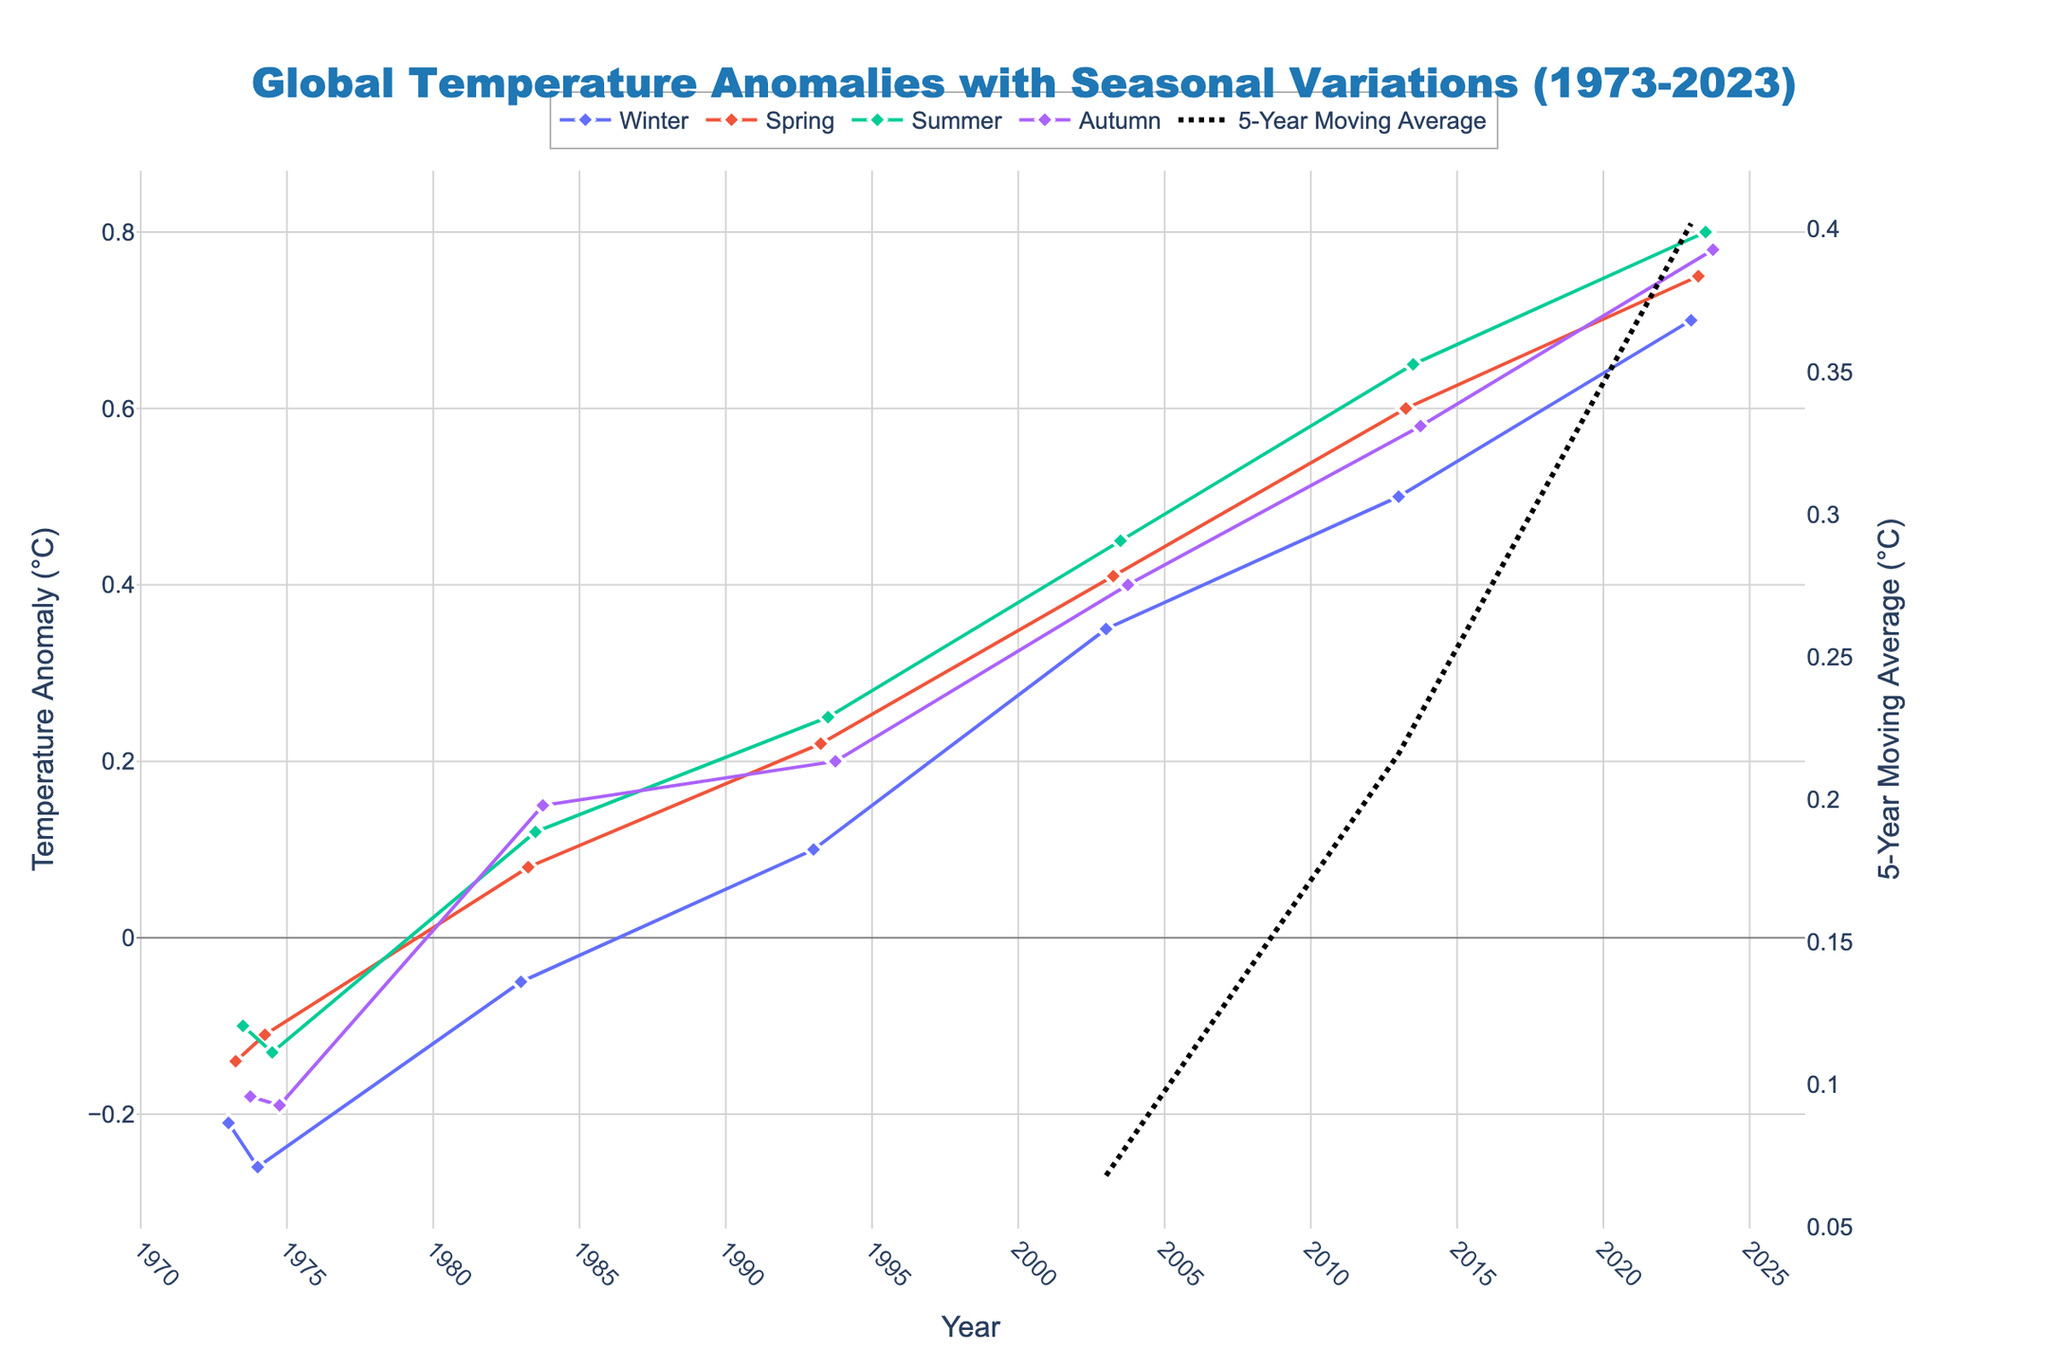What's the title of the figure? The title of the figure is displayed at the top center and reads "Global Temperature Anomalies with Seasonal Variations (1973-2023)"
Answer: Global Temperature Anomalies with Seasonal Variations (1973-2023) What are the y-axis labels? There are two y-axis labels on the figure. The label on the left y-axis reads "Temperature Anomaly (°C)", and the label on the right y-axis reads "5-Year Moving Average (°C)"
Answer: Temperature Anomaly (°C) and 5-Year Moving Average (°C) How does the temperature anomaly in Winter 2023 compare with Summer 2023? To compare the temperature anomaly values for Winter 2023 and Summer 2023, we locate both points on the graph. The Winter 2023 anomaly is 0.70°C and the Summer 2023 anomaly is 0.80°C. Therefore, the temperature anomaly in Summer 2023 is higher.
Answer: Summer 2023 is higher Which season shows the highest average temperature anomaly over the entire time period? To find the season with the highest average temperature anomaly, observe the overall trend lines for each season. The Summer trend line generally stays above others, indicating that Summer has the highest average temperature anomaly.
Answer: Summer What is the slope of the 5-Year Moving Average from 2003 to 2023? To determine the slope, we need the 5-Year Moving Average values at 2003 and 2023. From observation, the 5-Year Moving Average at 2003 is approximately 0.42°C and at 2023 is approximately 0.77°C. The slope is (0.77 - 0.42) / (2023 - 2003) = 0.35/20 = 0.0175 °C/year
Answer: 0.0175 °C/year Identify any visible outliers in the temperature anomaly data. To identify outliers, look for points that visibly deviate from the general trend. For example, in Winter 1974, there's a point at -0.26°C, which is notably lower than other surrounding points.
Answer: Winter 1974 (-0.26°C) Which year marks the first positive temperature anomaly across all seasons? By examining the figure, we observe that the year 1993 is when the temperature anomalies in all seasons became positive (Winter: 0.10, Spring: 0.22, Summer: 0.25, Autumn: 0.20).
Answer: 1993 What trend do you observe in the moving average from 1973 to 2023? The 5-Year Moving Average shows an increasing trend from 1973 to 2023. It starts negative, becomes positive around the mid-1980s, and continues to rise through the period.
Answer: Increasing trend What is the largest temperature anomaly observed, and in which season and year does it occur? To find the largest anomaly, inspect the peaks in the graph. The highest anomaly is around 0.80°C in Summer 2023.
Answer: Summer 2023, 0.80°C 